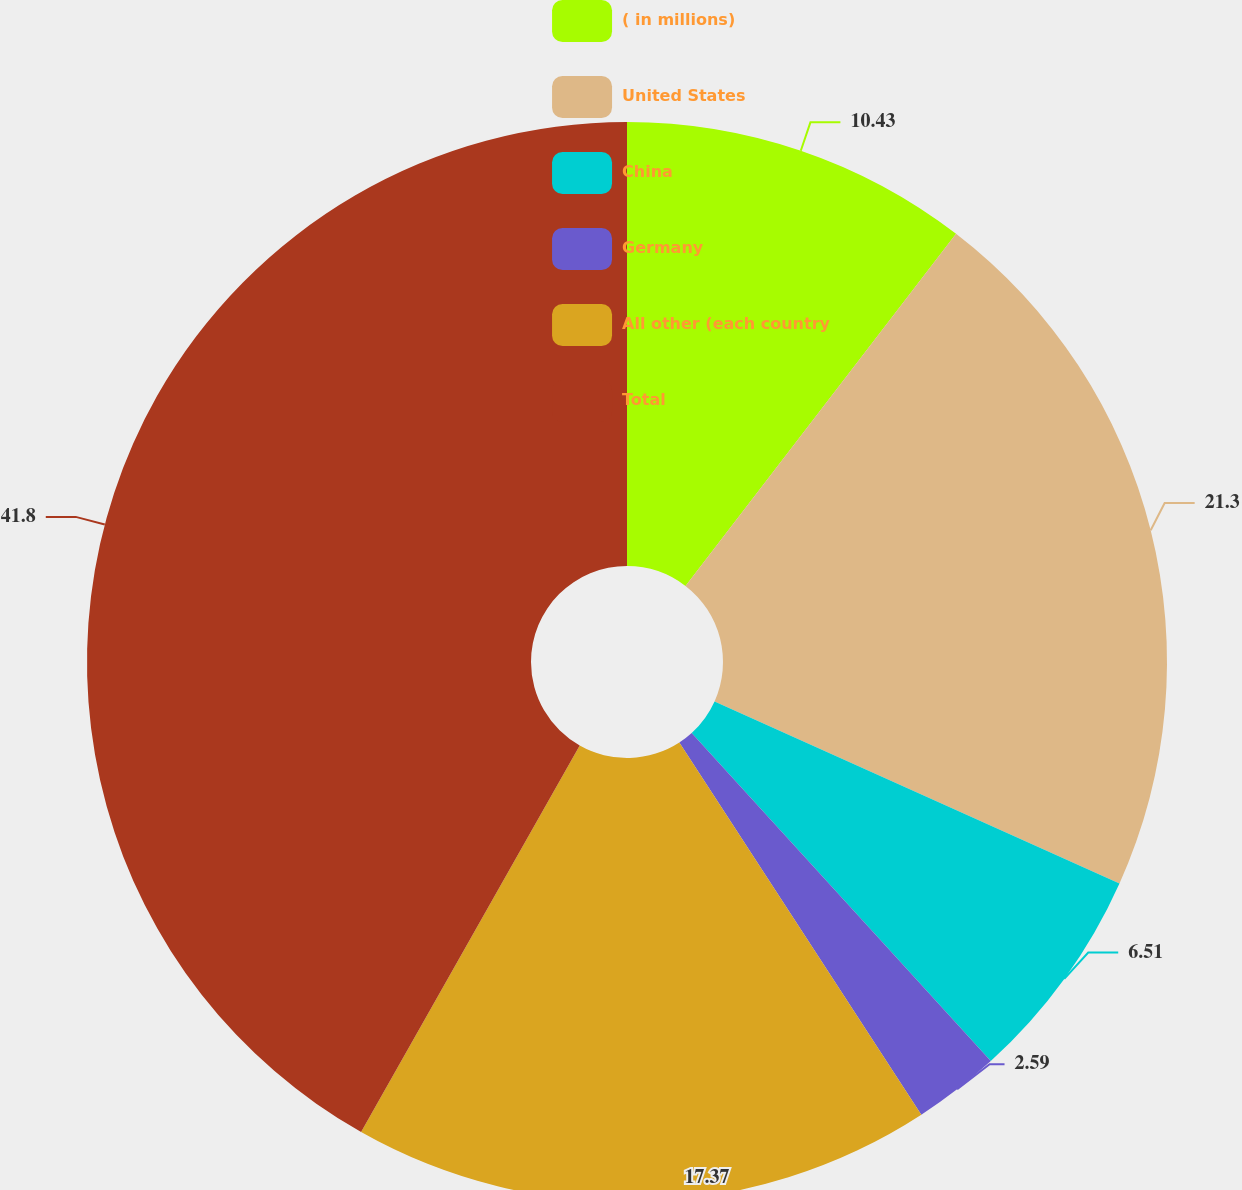Convert chart to OTSL. <chart><loc_0><loc_0><loc_500><loc_500><pie_chart><fcel>( in millions)<fcel>United States<fcel>China<fcel>Germany<fcel>All other (each country<fcel>Total<nl><fcel>10.43%<fcel>21.3%<fcel>6.51%<fcel>2.59%<fcel>17.37%<fcel>41.81%<nl></chart> 